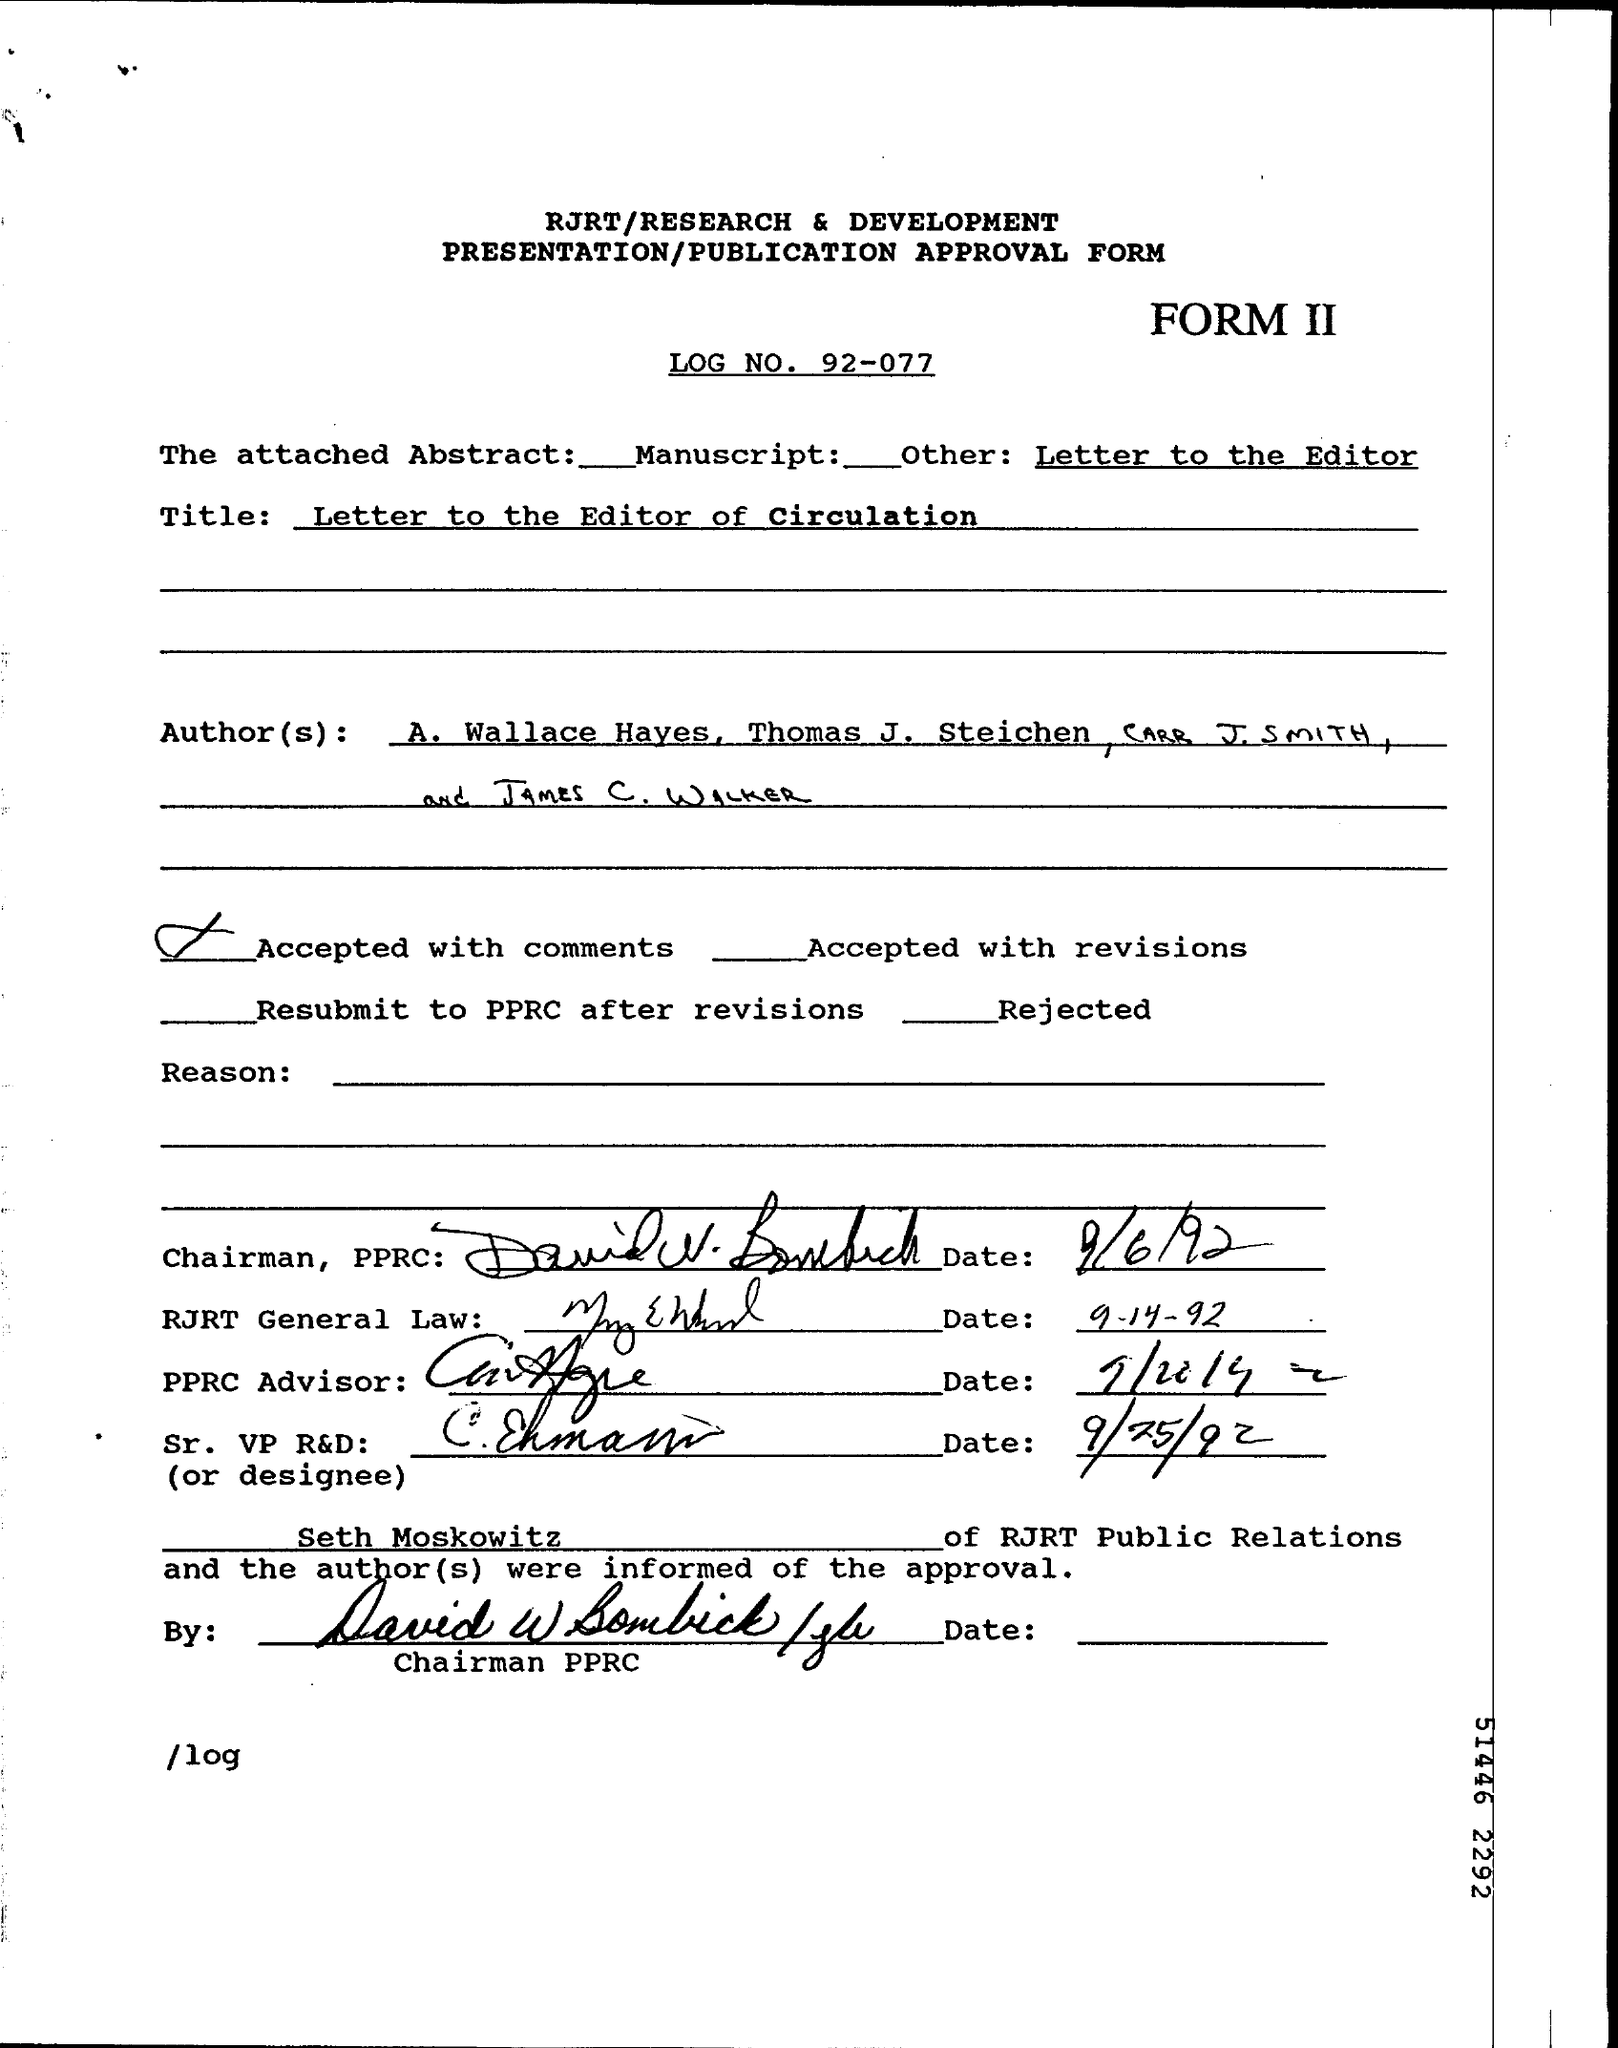What is the date of signature of Chairman?
Give a very brief answer. 9/6/92. What is mentioned as "Title"?
Offer a very short reply. Letter to the Editor of Circulation. What is attached abstract?
Offer a terse response. Manuscript. What is log no:?
Your response must be concise. 92-077. What is form No:?
Make the answer very short. II. 